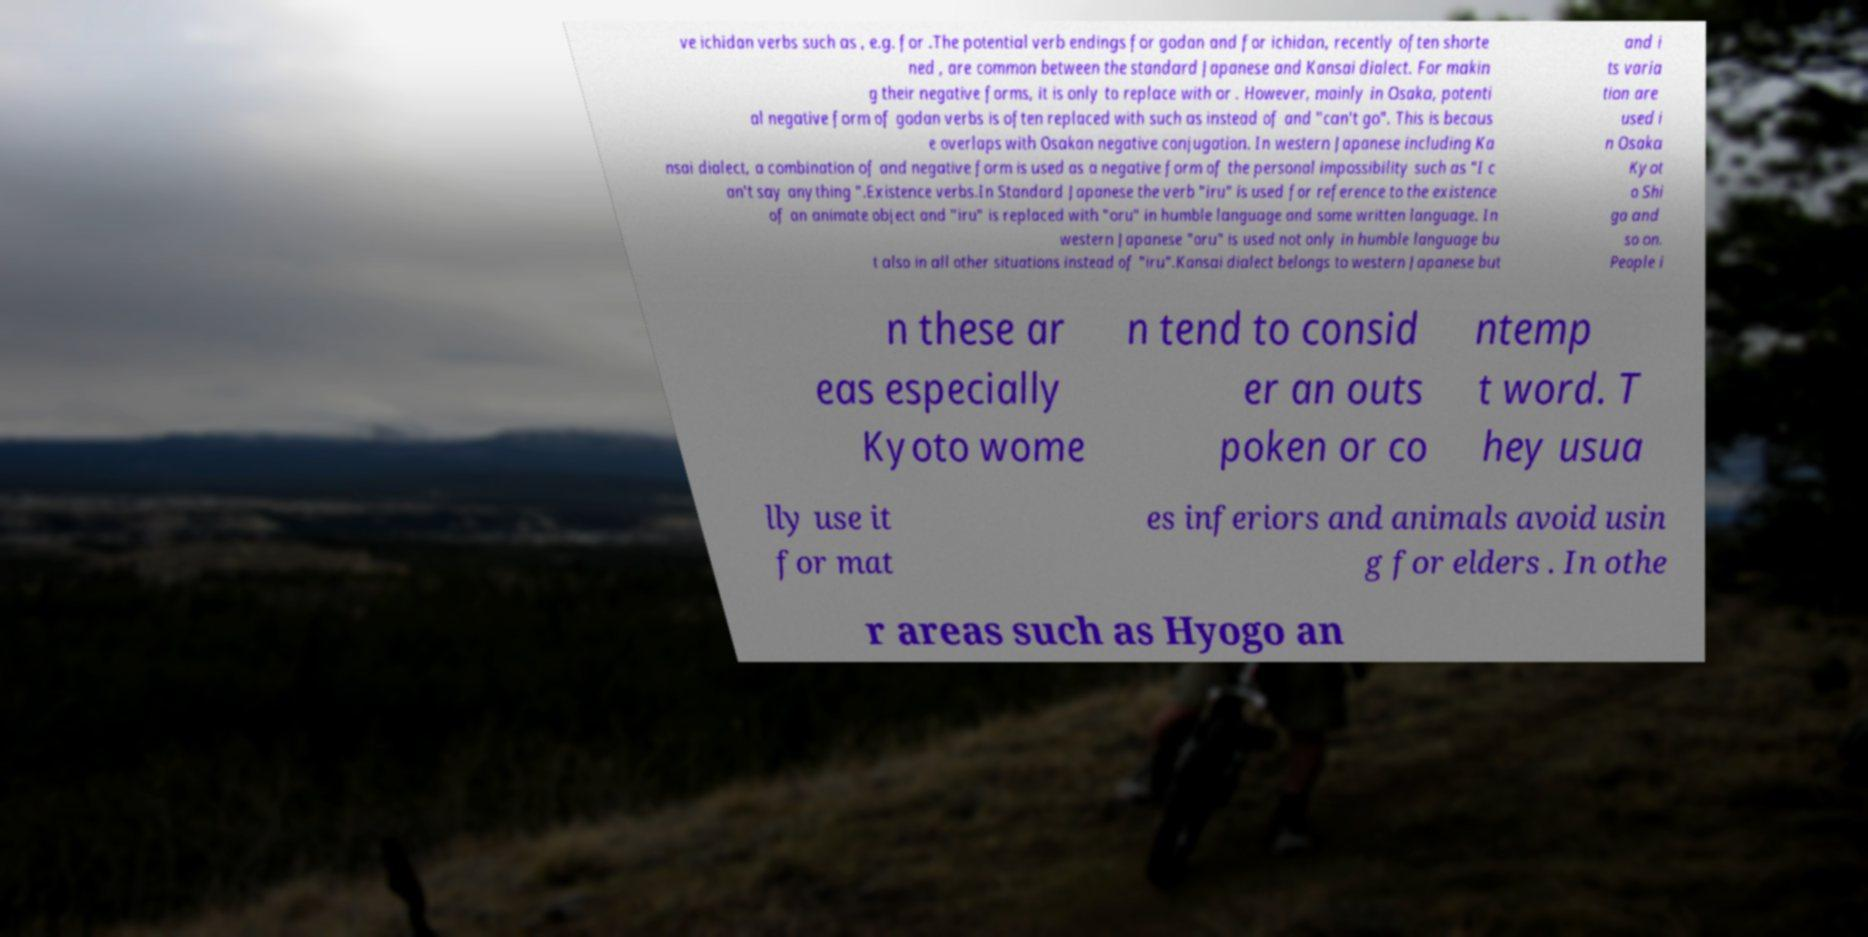Please identify and transcribe the text found in this image. ve ichidan verbs such as , e.g. for .The potential verb endings for godan and for ichidan, recently often shorte ned , are common between the standard Japanese and Kansai dialect. For makin g their negative forms, it is only to replace with or . However, mainly in Osaka, potenti al negative form of godan verbs is often replaced with such as instead of and "can't go". This is becaus e overlaps with Osakan negative conjugation. In western Japanese including Ka nsai dialect, a combination of and negative form is used as a negative form of the personal impossibility such as "I c an't say anything ".Existence verbs.In Standard Japanese the verb "iru" is used for reference to the existence of an animate object and "iru" is replaced with "oru" in humble language and some written language. In western Japanese "oru" is used not only in humble language bu t also in all other situations instead of "iru".Kansai dialect belongs to western Japanese but and i ts varia tion are used i n Osaka Kyot o Shi ga and so on. People i n these ar eas especially Kyoto wome n tend to consid er an outs poken or co ntemp t word. T hey usua lly use it for mat es inferiors and animals avoid usin g for elders . In othe r areas such as Hyogo an 